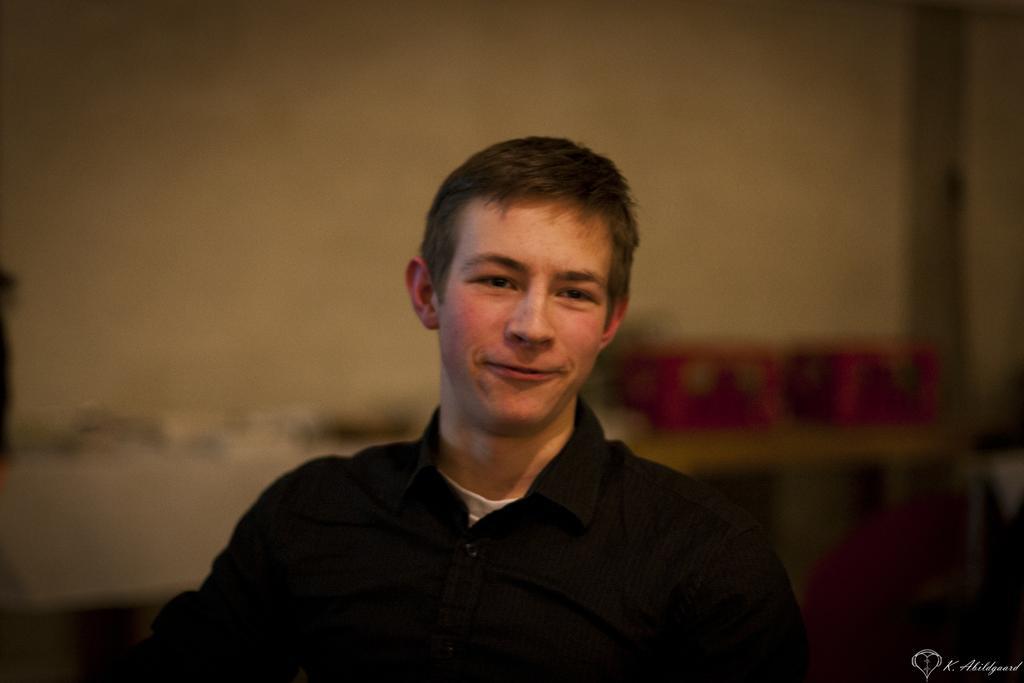Could you give a brief overview of what you see in this image? In this picture I can see a man in front, who is wearing black color shirt and I can see the watermark on the right bottom corner of this image. I see that it is blurred in the background. 